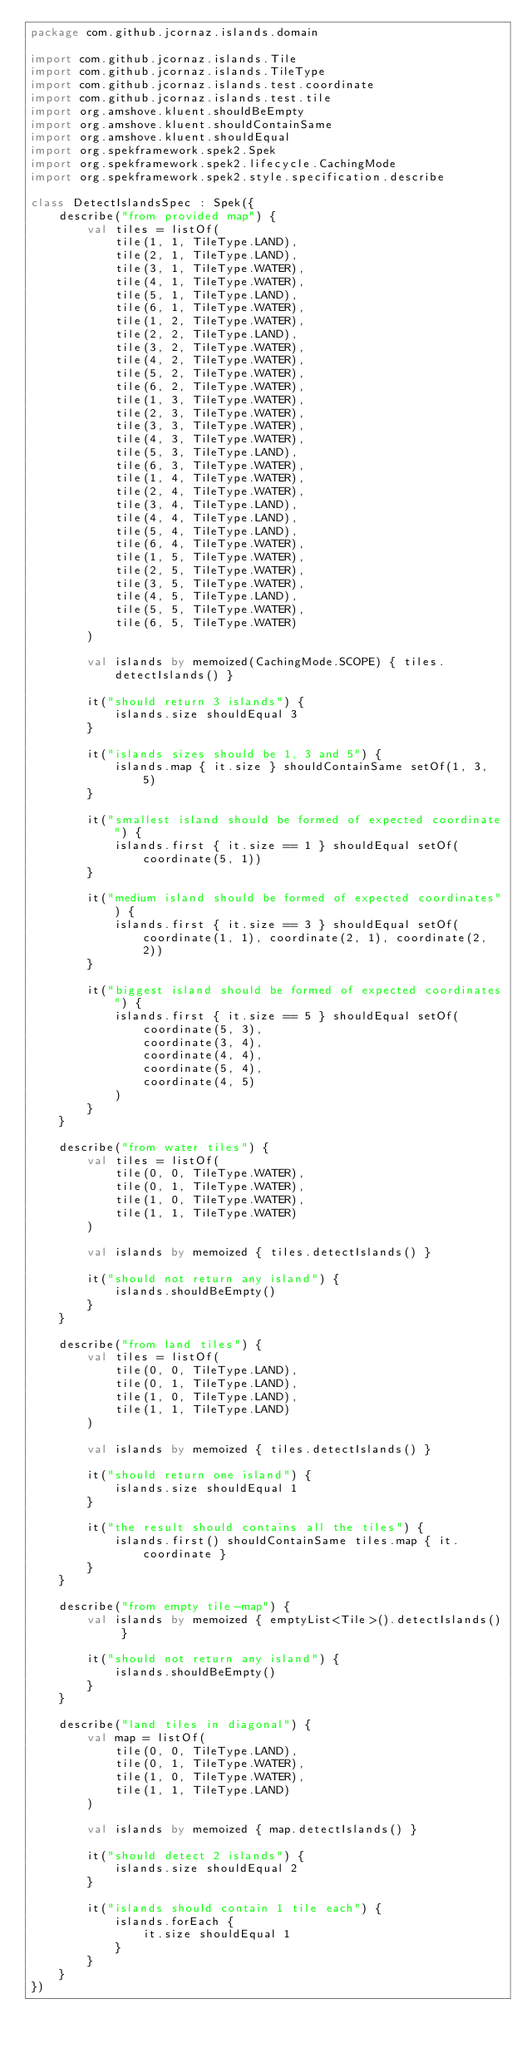Convert code to text. <code><loc_0><loc_0><loc_500><loc_500><_Kotlin_>package com.github.jcornaz.islands.domain

import com.github.jcornaz.islands.Tile
import com.github.jcornaz.islands.TileType
import com.github.jcornaz.islands.test.coordinate
import com.github.jcornaz.islands.test.tile
import org.amshove.kluent.shouldBeEmpty
import org.amshove.kluent.shouldContainSame
import org.amshove.kluent.shouldEqual
import org.spekframework.spek2.Spek
import org.spekframework.spek2.lifecycle.CachingMode
import org.spekframework.spek2.style.specification.describe

class DetectIslandsSpec : Spek({
    describe("from provided map") {
        val tiles = listOf(
            tile(1, 1, TileType.LAND),
            tile(2, 1, TileType.LAND),
            tile(3, 1, TileType.WATER),
            tile(4, 1, TileType.WATER),
            tile(5, 1, TileType.LAND),
            tile(6, 1, TileType.WATER),
            tile(1, 2, TileType.WATER),
            tile(2, 2, TileType.LAND),
            tile(3, 2, TileType.WATER),
            tile(4, 2, TileType.WATER),
            tile(5, 2, TileType.WATER),
            tile(6, 2, TileType.WATER),
            tile(1, 3, TileType.WATER),
            tile(2, 3, TileType.WATER),
            tile(3, 3, TileType.WATER),
            tile(4, 3, TileType.WATER),
            tile(5, 3, TileType.LAND),
            tile(6, 3, TileType.WATER),
            tile(1, 4, TileType.WATER),
            tile(2, 4, TileType.WATER),
            tile(3, 4, TileType.LAND),
            tile(4, 4, TileType.LAND),
            tile(5, 4, TileType.LAND),
            tile(6, 4, TileType.WATER),
            tile(1, 5, TileType.WATER),
            tile(2, 5, TileType.WATER),
            tile(3, 5, TileType.WATER),
            tile(4, 5, TileType.LAND),
            tile(5, 5, TileType.WATER),
            tile(6, 5, TileType.WATER)
        )

        val islands by memoized(CachingMode.SCOPE) { tiles.detectIslands() }

        it("should return 3 islands") {
            islands.size shouldEqual 3
        }

        it("islands sizes should be 1, 3 and 5") {
            islands.map { it.size } shouldContainSame setOf(1, 3, 5)
        }

        it("smallest island should be formed of expected coordinate") {
            islands.first { it.size == 1 } shouldEqual setOf(coordinate(5, 1))
        }

        it("medium island should be formed of expected coordinates") {
            islands.first { it.size == 3 } shouldEqual setOf(coordinate(1, 1), coordinate(2, 1), coordinate(2, 2))
        }

        it("biggest island should be formed of expected coordinates") {
            islands.first { it.size == 5 } shouldEqual setOf(
                coordinate(5, 3),
                coordinate(3, 4),
                coordinate(4, 4),
                coordinate(5, 4),
                coordinate(4, 5)
            )
        }
    }

    describe("from water tiles") {
        val tiles = listOf(
            tile(0, 0, TileType.WATER),
            tile(0, 1, TileType.WATER),
            tile(1, 0, TileType.WATER),
            tile(1, 1, TileType.WATER)
        )

        val islands by memoized { tiles.detectIslands() }

        it("should not return any island") {
            islands.shouldBeEmpty()
        }
    }

    describe("from land tiles") {
        val tiles = listOf(
            tile(0, 0, TileType.LAND),
            tile(0, 1, TileType.LAND),
            tile(1, 0, TileType.LAND),
            tile(1, 1, TileType.LAND)
        )

        val islands by memoized { tiles.detectIslands() }

        it("should return one island") {
            islands.size shouldEqual 1
        }

        it("the result should contains all the tiles") {
            islands.first() shouldContainSame tiles.map { it.coordinate }
        }
    }

    describe("from empty tile-map") {
        val islands by memoized { emptyList<Tile>().detectIslands() }

        it("should not return any island") {
            islands.shouldBeEmpty()
        }
    }

    describe("land tiles in diagonal") {
        val map = listOf(
            tile(0, 0, TileType.LAND),
            tile(0, 1, TileType.WATER),
            tile(1, 0, TileType.WATER),
            tile(1, 1, TileType.LAND)
        )

        val islands by memoized { map.detectIslands() }

        it("should detect 2 islands") {
            islands.size shouldEqual 2
        }

        it("islands should contain 1 tile each") {
            islands.forEach {
                it.size shouldEqual 1
            }
        }
    }
})
</code> 